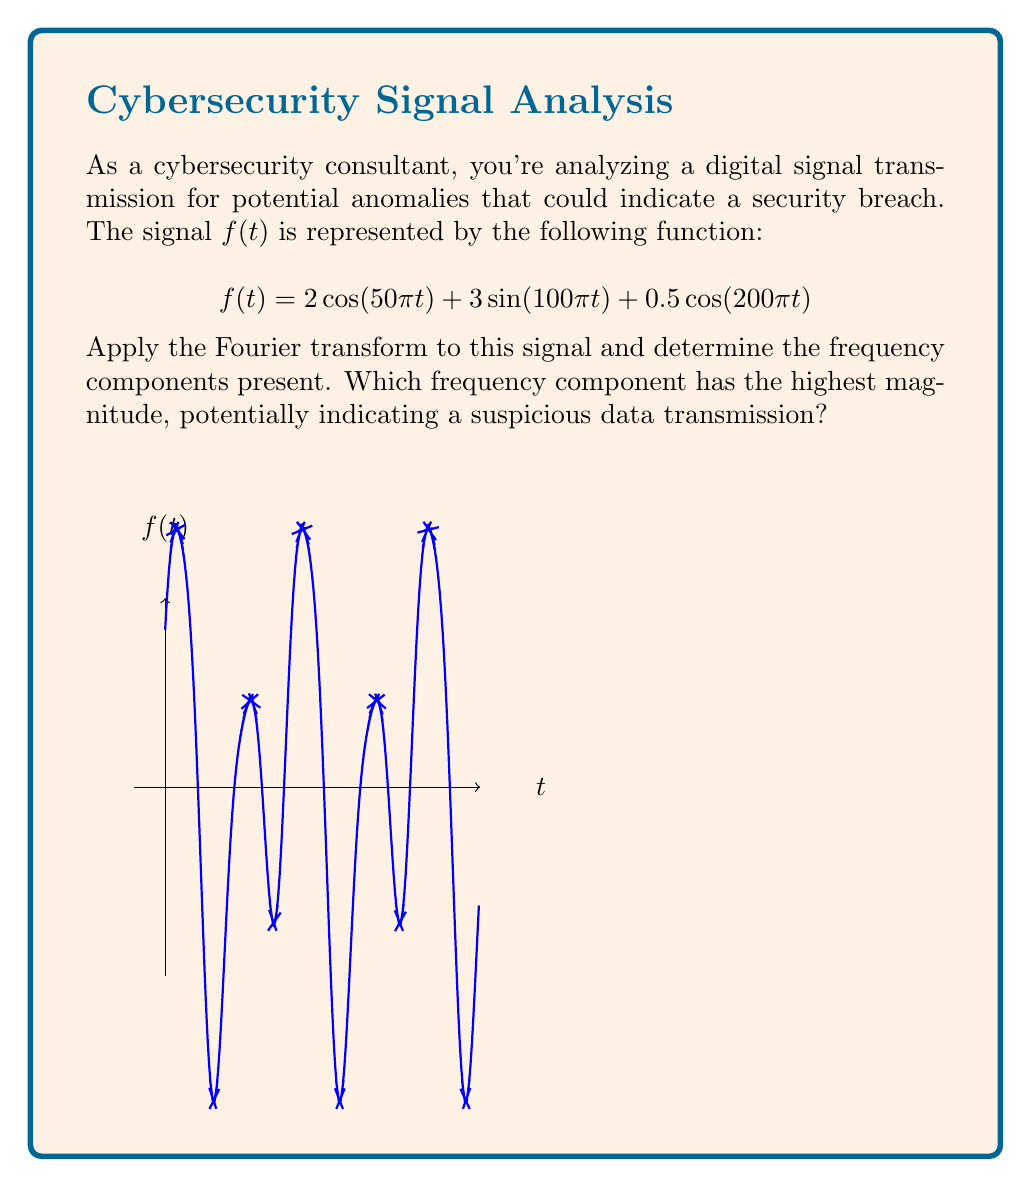Help me with this question. To solve this problem, we'll follow these steps:

1) Recall the Fourier transform pairs for cosine and sine functions:
   $$\mathcal{F}\{\cos(\omega t)\} = \pi[\delta(\omega - \omega_0) + \delta(\omega + \omega_0)]$$
   $$\mathcal{F}\{\sin(\omega t)\} = \frac{\pi}{i}[\delta(\omega - \omega_0) - \delta(\omega + \omega_0)]$$

2) Apply the Fourier transform to each term of $f(t)$:

   For $2\cos(50\pi t)$:
   $$\mathcal{F}\{2\cos(50\pi t)\} = 2\pi[\delta(\omega - 25) + \delta(\omega + 25)]$$

   For $3\sin(100\pi t)$:
   $$\mathcal{F}\{3\sin(100\pi t)\} = \frac{3\pi}{i}[\delta(\omega - 50) - \delta(\omega + 50)]$$

   For $0.5\cos(200\pi t)$:
   $$\mathcal{F}\{0.5\cos(200\pi t)\} = 0.5\pi[\delta(\omega - 100) + \delta(\omega + 100)]$$

3) The complete Fourier transform is the sum of these components:

   $$F(\omega) = 2\pi[\delta(\omega - 25) + \delta(\omega + 25)] + \frac{3\pi}{i}[\delta(\omega - 50) - \delta(\omega + 50)] + 0.5\pi[\delta(\omega - 100) + \delta(\omega + 100)]$$

4) To find the magnitude of each component, we need to consider the absolute value:
   - At $\omega = \pm 25$ Hz: $|2\pi| = 2\pi$
   - At $\omega = \pm 50$ Hz: $|\frac{3\pi}{i}| = 3\pi$
   - At $\omega = \pm 100$ Hz: $|0.5\pi| = 0.5\pi$

5) The component with the highest magnitude is at $\omega = \pm 50$ Hz, corresponding to the $3\sin(100\pi t)$ term in the original signal.
Answer: 50 Hz 